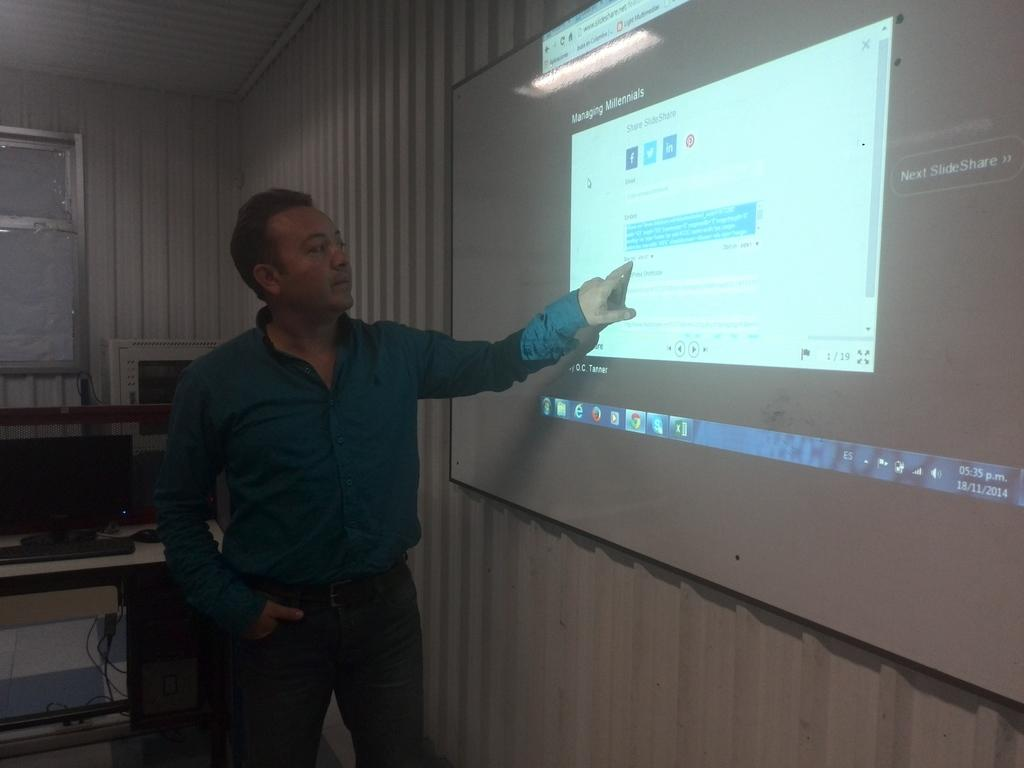Provide a one-sentence caption for the provided image. Man pointing at screen projection of A PC screen. 